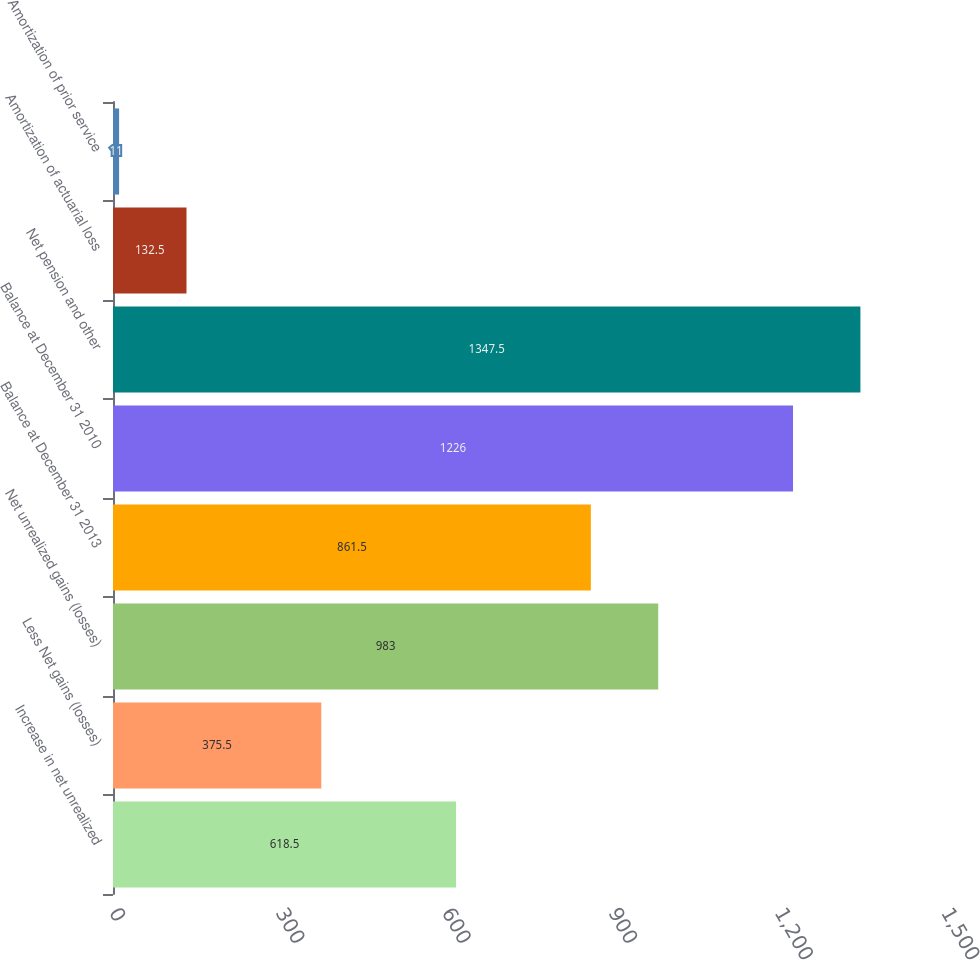<chart> <loc_0><loc_0><loc_500><loc_500><bar_chart><fcel>Increase in net unrealized<fcel>Less Net gains (losses)<fcel>Net unrealized gains (losses)<fcel>Balance at December 31 2013<fcel>Balance at December 31 2010<fcel>Net pension and other<fcel>Amortization of actuarial loss<fcel>Amortization of prior service<nl><fcel>618.5<fcel>375.5<fcel>983<fcel>861.5<fcel>1226<fcel>1347.5<fcel>132.5<fcel>11<nl></chart> 